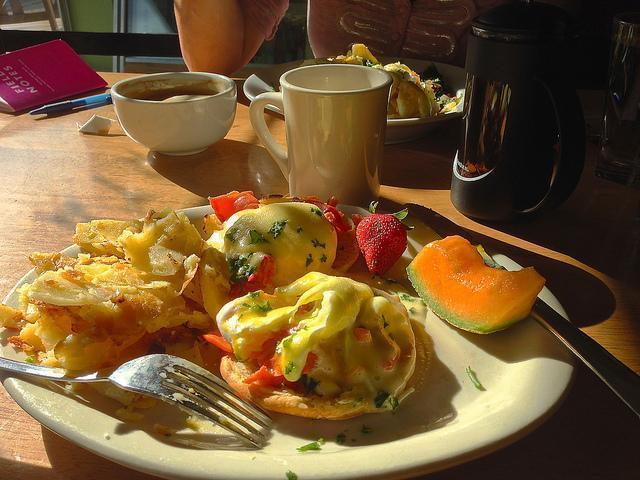What is the yellow sauce's name in the culinary world?
Choose the correct response, then elucidate: 'Answer: answer
Rationale: rationale.'
Options: Bearnaise, hollandaise, bechamel, choron. Answer: hollandaise.
Rationale: It is used a lot on eggs. 